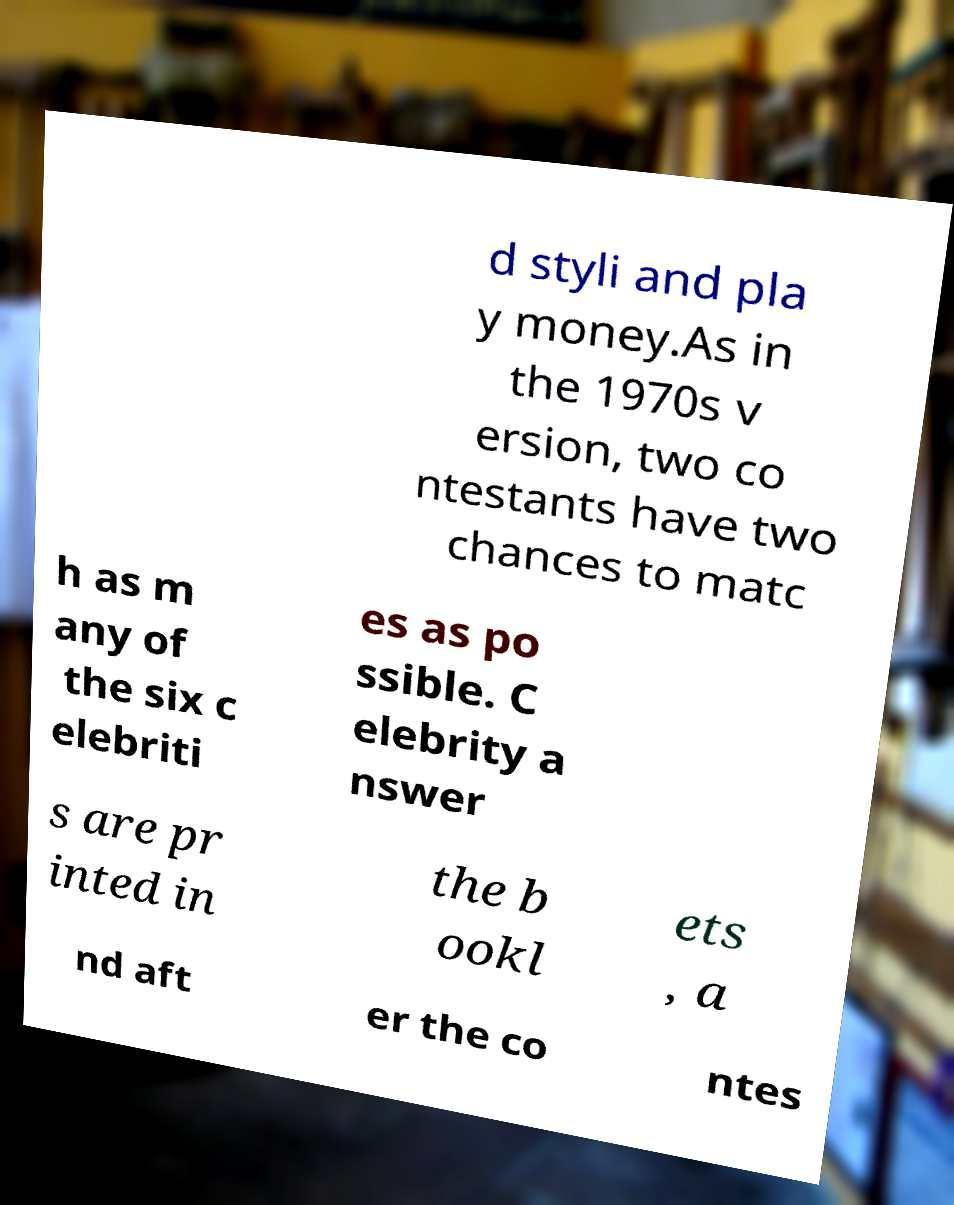Can you read and provide the text displayed in the image?This photo seems to have some interesting text. Can you extract and type it out for me? d styli and pla y money.As in the 1970s v ersion, two co ntestants have two chances to matc h as m any of the six c elebriti es as po ssible. C elebrity a nswer s are pr inted in the b ookl ets , a nd aft er the co ntes 